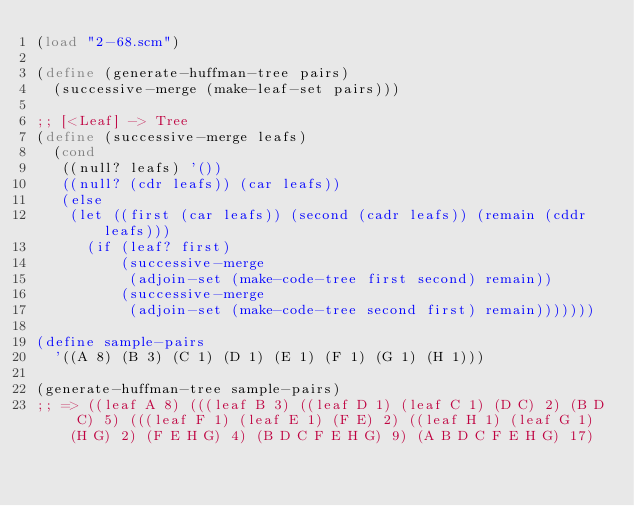<code> <loc_0><loc_0><loc_500><loc_500><_Scheme_>(load "2-68.scm")

(define (generate-huffman-tree pairs)
  (successive-merge (make-leaf-set pairs)))

;; [<Leaf] -> Tree
(define (successive-merge leafs)
  (cond
   ((null? leafs) '())
   ((null? (cdr leafs)) (car leafs))
   (else
    (let ((first (car leafs)) (second (cadr leafs)) (remain (cddr leafs)))
      (if (leaf? first)
          (successive-merge
           (adjoin-set (make-code-tree first second) remain))
          (successive-merge
           (adjoin-set (make-code-tree second first) remain)))))))

(define sample-pairs
  '((A 8) (B 3) (C 1) (D 1) (E 1) (F 1) (G 1) (H 1)))

(generate-huffman-tree sample-pairs)
;; => ((leaf A 8) (((leaf B 3) ((leaf D 1) (leaf C 1) (D C) 2) (B D C) 5) (((leaf F 1) (leaf E 1) (F E) 2) ((leaf H 1) (leaf G 1) (H G) 2) (F E H G) 4) (B D C F E H G) 9) (A B D C F E H G) 17)
</code> 